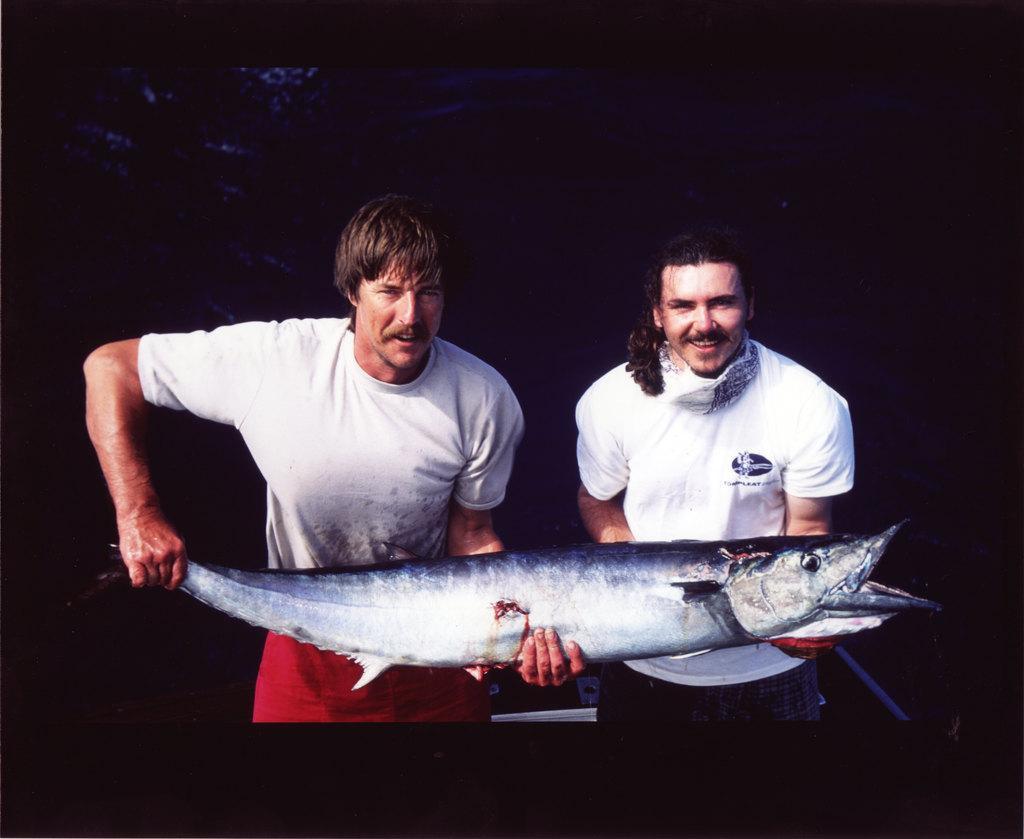How would you summarize this image in a sentence or two? Two people are holding fish. In the background it is dark. 